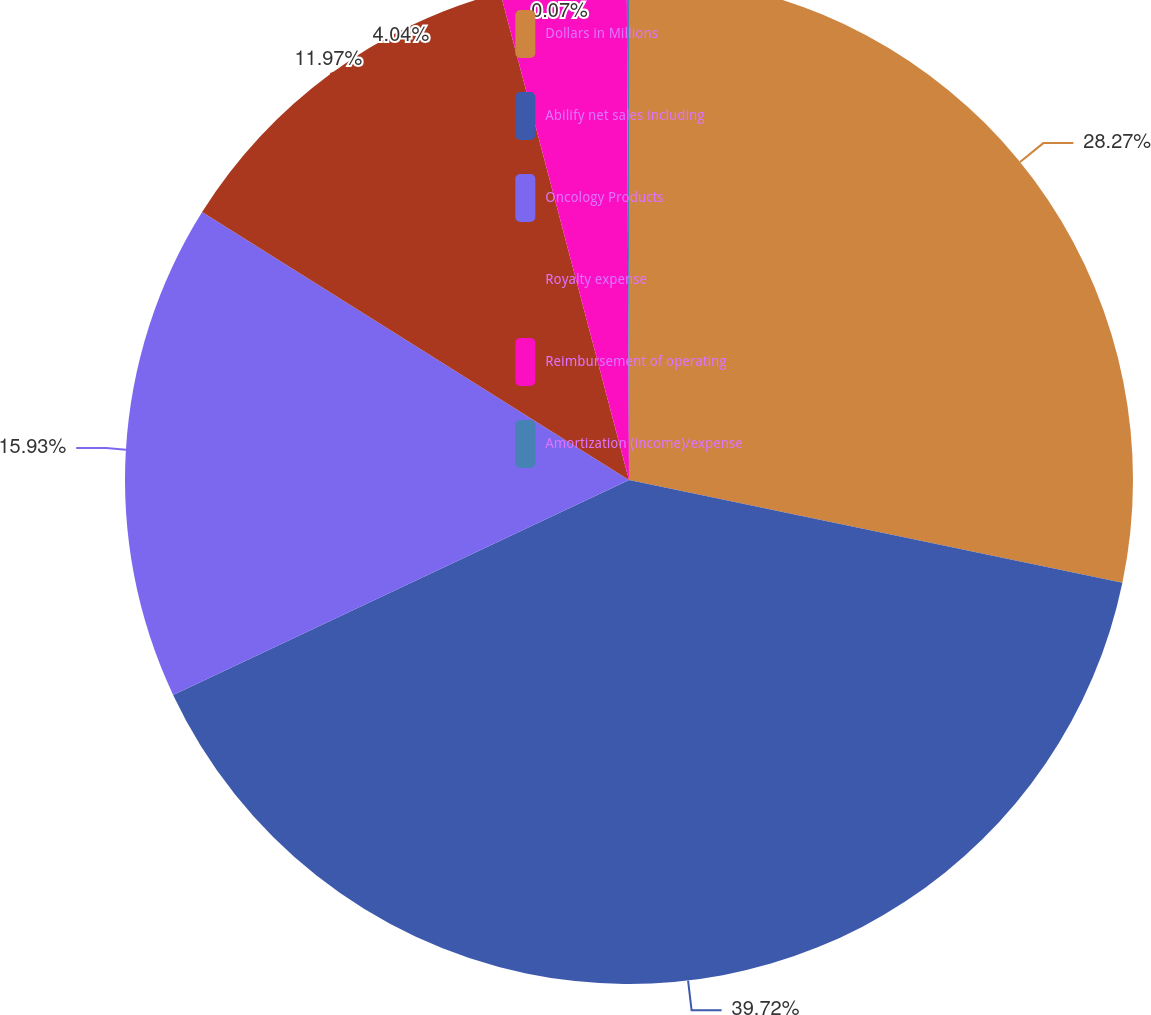<chart> <loc_0><loc_0><loc_500><loc_500><pie_chart><fcel>Dollars in Millions<fcel>Abilify net sales including<fcel>Oncology Products<fcel>Royalty expense<fcel>Reimbursement of operating<fcel>Amortization (income)/expense<nl><fcel>28.27%<fcel>39.72%<fcel>15.93%<fcel>11.97%<fcel>4.04%<fcel>0.07%<nl></chart> 